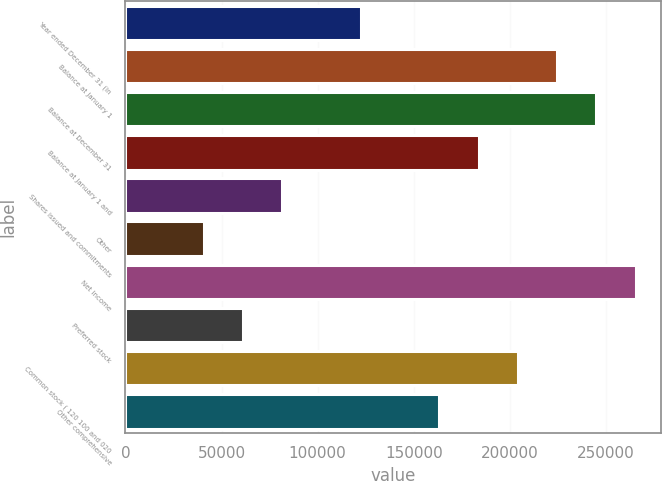Convert chart. <chart><loc_0><loc_0><loc_500><loc_500><bar_chart><fcel>Year ended December 31 (in<fcel>Balance at January 1<fcel>Balance at December 31<fcel>Balance at January 1 and<fcel>Shares issued and commitments<fcel>Other<fcel>Net income<fcel>Preferred stock<fcel>Common stock ( 120 100 and 020<fcel>Other comprehensive<nl><fcel>122444<fcel>224475<fcel>244882<fcel>183663<fcel>81631.2<fcel>40818.6<fcel>265288<fcel>61224.9<fcel>204069<fcel>163256<nl></chart> 